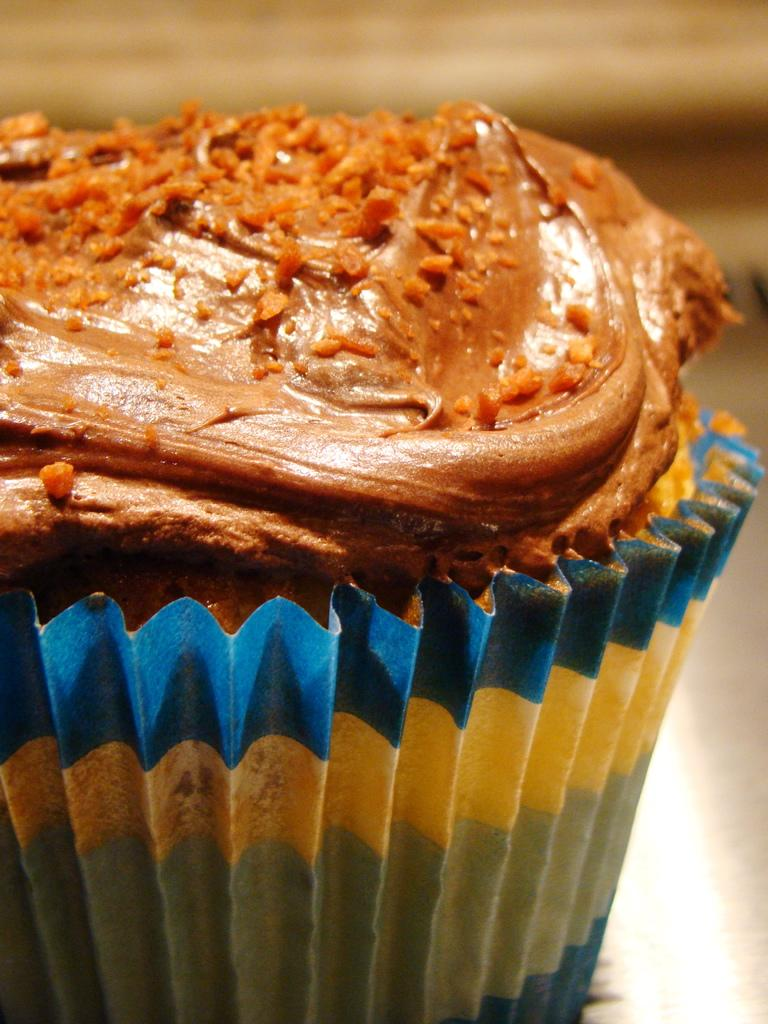What type of items can be seen in the image? The image contains food. What type of industry can be seen in the image? There is no industry present in the image; it contains food. Is there a balance beam visible in the image? There is no balance beam present in the image; it contains food. 